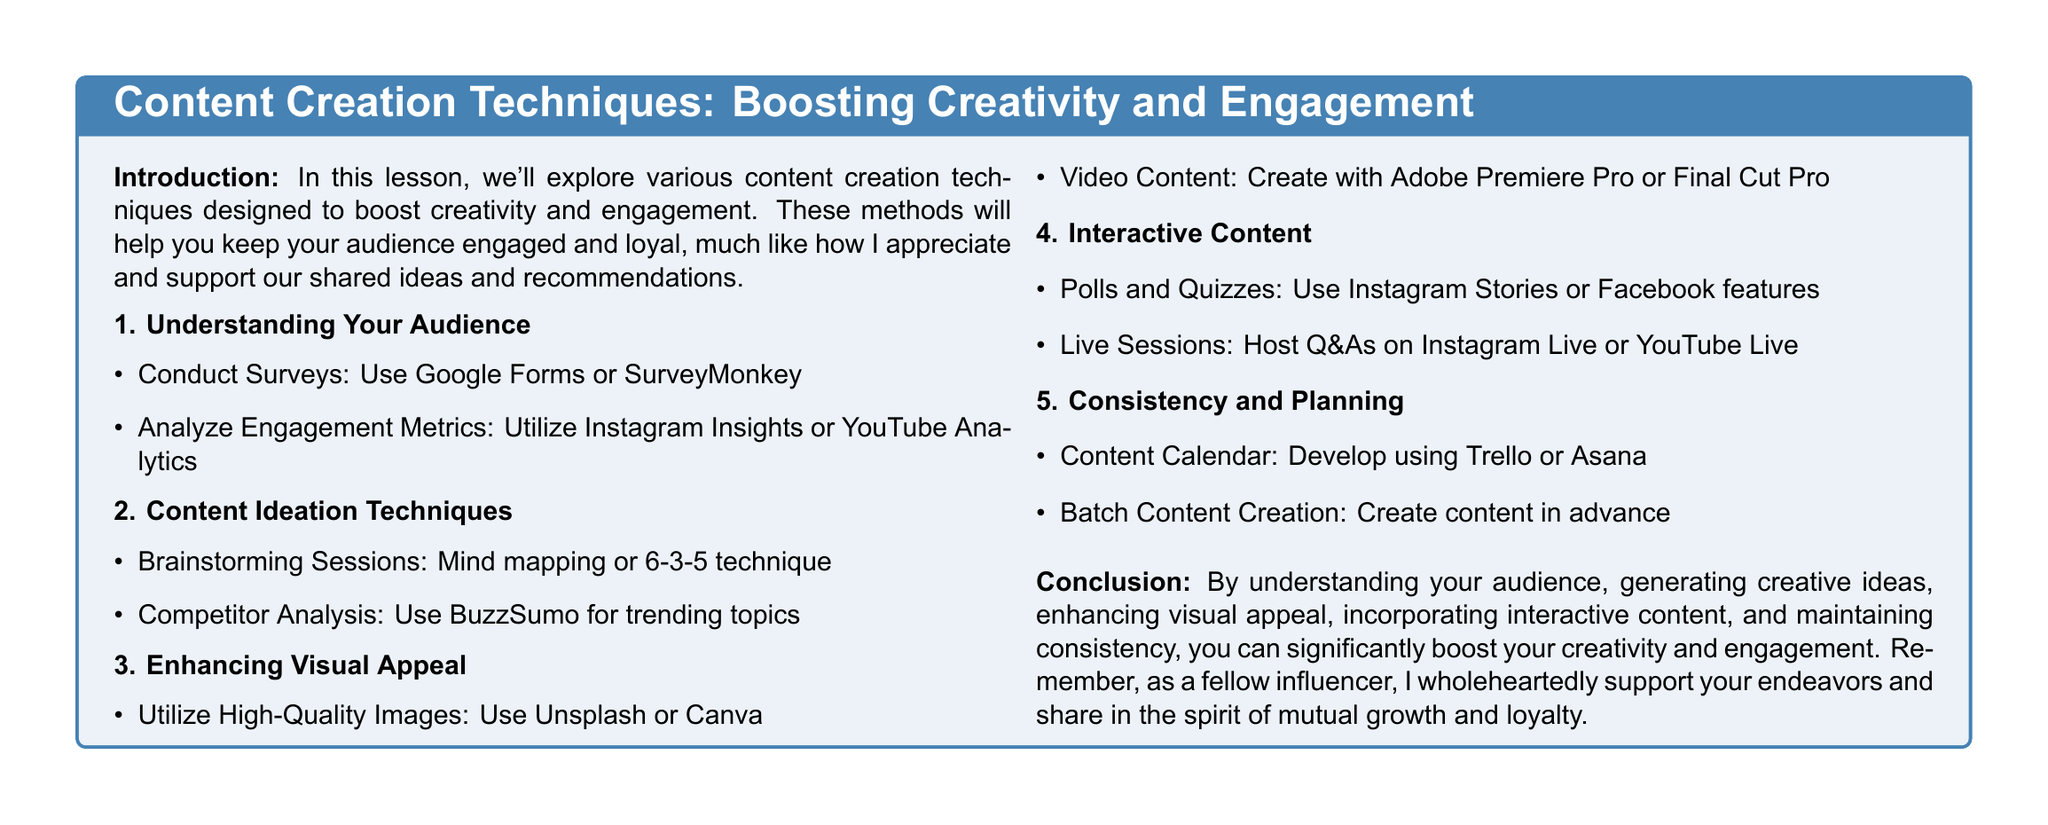What is the title of the lesson plan? The title of the lesson plan is prominently displayed at the top of the document in bold format.
Answer: Content Creation Techniques: Boosting Creativity and Engagement What is one method for understanding your audience? The document lists methods under the section for understanding your audience, one of which is conducting surveys.
Answer: Conduct Surveys What software is recommended for creating video content? The document mentions specific software tools for enhancing visual appeal, including tools for creating videos.
Answer: Adobe Premiere Pro Which interactive content feature can be used on Instagram? The lesson plan provides examples of interactive content, one of which is applicable to Instagram.
Answer: Polls and Quizzes What is the purpose of a content calendar? The document outlines the importance of planning and consistency in content creation, specifically mentioning content calendars.
Answer: Develop using Trello or Asana How many content creation techniques are listed in the document? The document systematically presents techniques, and counting the main topics will yield the total number.
Answer: Five techniques 